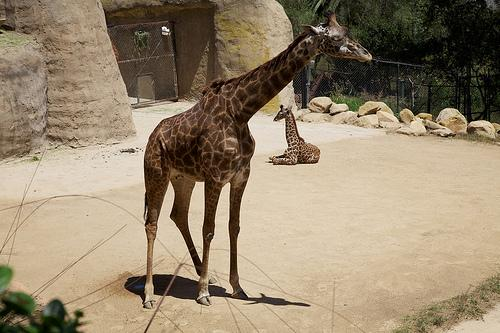Provide a summary of the most prominent objects in the image. The image features multiple giraffes in various positions and a pile of rocks, along with smaller rocks, a fence, and some plants in the foreground and background. What are the main objects interacting within the image, and how many of them are present? The main objects are giraffes and rocks, with several giraffes in various positions and a pile of rocks along with smaller individual rocks. What is the primary focus of the image, and what are the main activities happening within it? The primary focus of the image is on giraffes, some of which are sitting, laying down, or standing up. There are also piles of rocks and a fence in the scene. Explain any complex reasoning that can be derived from the image objects and their interactions. We can deduce that the giraffes are in a safe environment, possibly a zoo or sanctuary, due to their relaxed positions and the presence of fences in the background. Identify and count the types of rocks present in the image. There are large rock formations, a pile of rocks, and several individual smaller rocks that are described as being next to each other, totaling three types of rocks. Evaluate the fencing element within the image and its possible purpose. The fence appears in the background and may serve as a boundary or enclosure for the giraffes, suggesting that they are in a controlled environment like a zoo or wildlife sanctuary. Describe the interaction between the giraffes and the environment. The giraffes are present in various positions, such as sitting or laying down on the ground, while some are standing up in the zoo-like setting with rocks and a fence in the background. Based on the image's content and object positions, is it a high-quality and well-composed photograph? It appears to be a well-composed image with the focus on multiple giraffe subjects, their interactions, and the environment, including rocks, plants, and a fence. What kind of sentiments and emotions can be perceived from this image? The image evokes a sense of curiosity and wonder while observing the various positions and interactions of the giraffes in their habitat. How many giraffes are on the ground, and what are they doing? There are multiple giraffes on the ground, some sitting, laying down, or looking around. There is also a baby giraffe present in the image. 